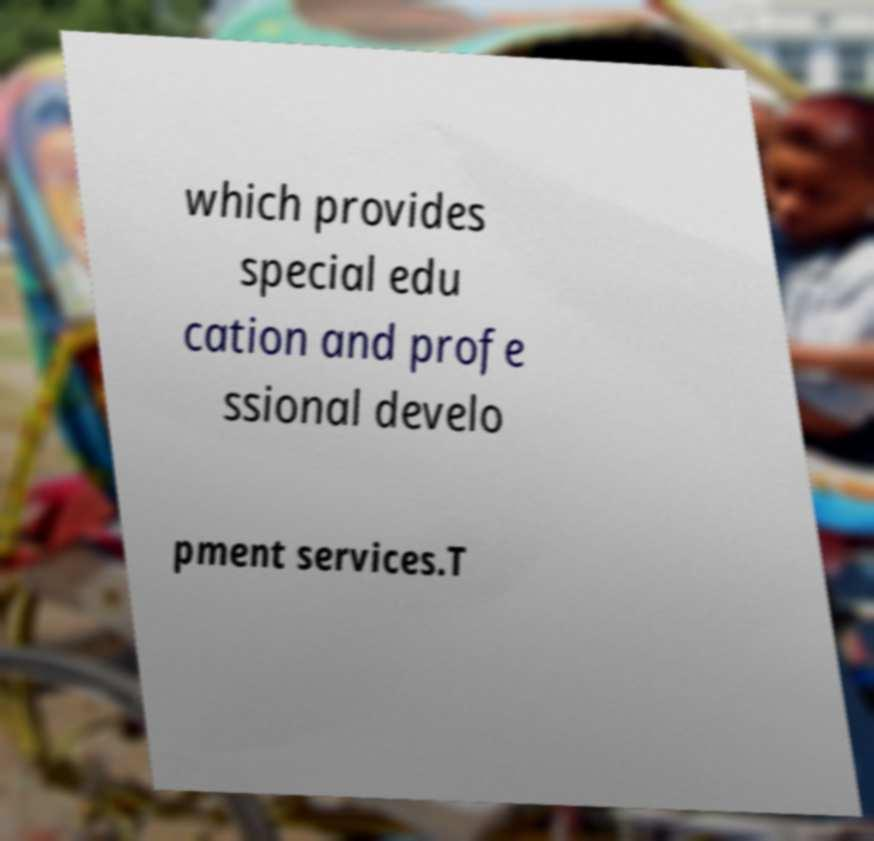Could you extract and type out the text from this image? which provides special edu cation and profe ssional develo pment services.T 